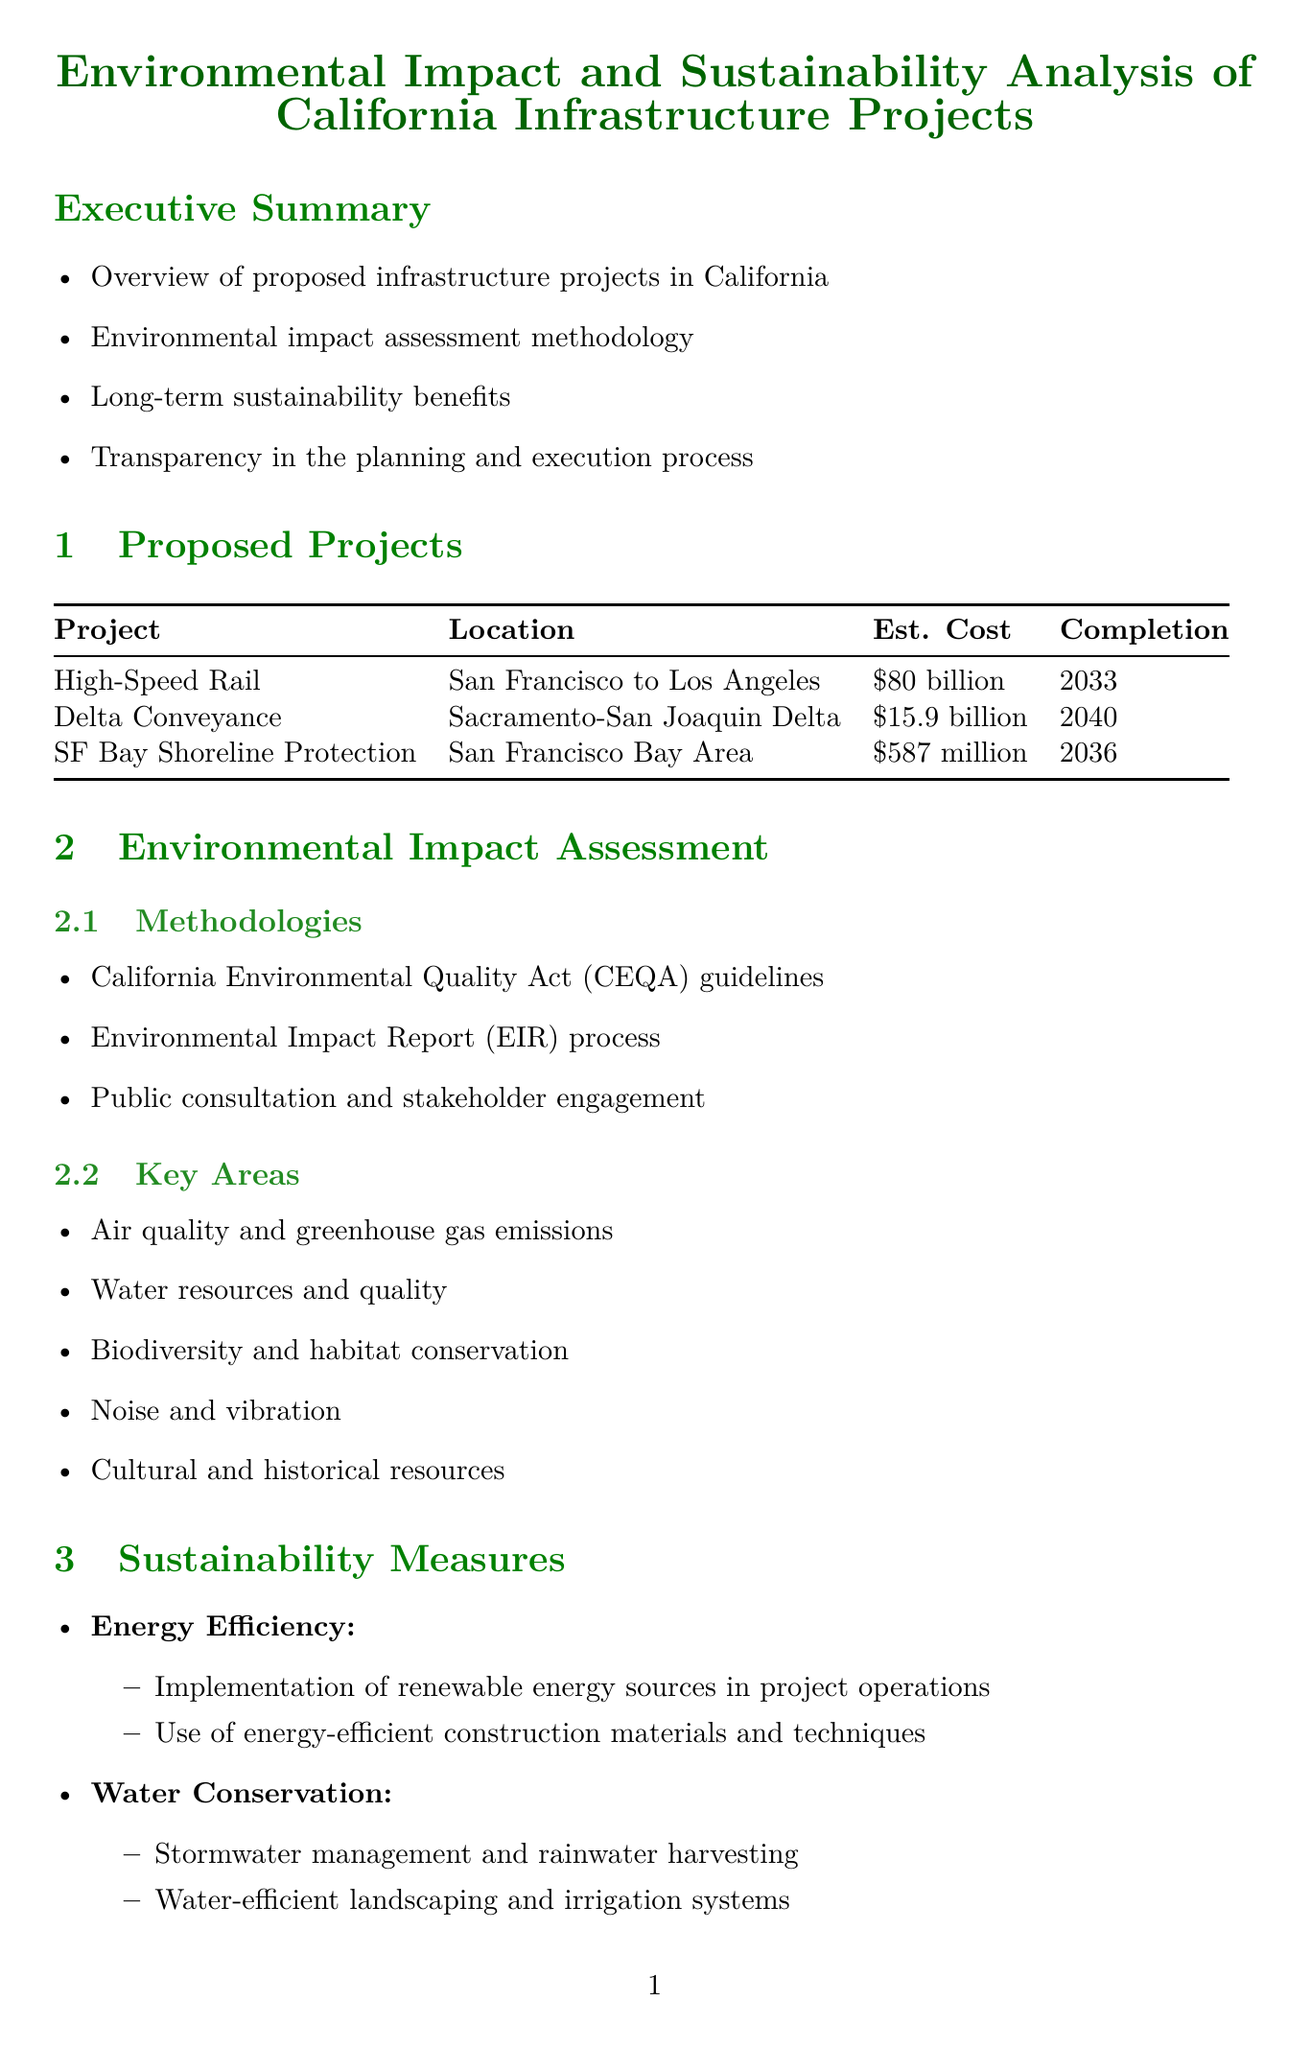What is the estimated cost of the High-Speed Rail Project? The estimated cost of the High-Speed Rail Project is listed in the document as $80 billion.
Answer: $80 billion What are the expected completion years for the Delta Conveyance Project? The expected completion year for the Delta Conveyance Project is clearly stated in the document as 2040.
Answer: 2040 Which assessment methodology is mentioned first in the Environmental Impact Assessment section? The methodologies section lists California Environmental Quality Act (CEQA) guidelines as the first assessment methodology.
Answer: California Environmental Quality Act (CEQA) guidelines What type of measures are included under the category of Water Conservation? Water Conservation measures include examples like stormwater management and rainwater harvesting listed in the sustainability measures.
Answer: Stormwater management and rainwater harvesting What initiative provides real-time updates on project progress? The initiative mentioned in the document that provides real-time updates on project progress is the California Infrastructure Transparency Portal.
Answer: California Infrastructure Transparency Portal How many long-term benefits are listed in the report? The document enumerates five distinct long-term benefits presented in the Long-Term Benefits section.
Answer: Five Who is the lead agency for transportation projects according to the key stakeholders? The California Department of Transportation (Caltrans) is identified in the document as the lead agency for transportation projects.
Answer: California Department of Transportation (Caltrans) What does the conclusion of the report signify about the proposed projects? The conclusion indicates a commitment to long-term sustainability and environmental stewardship in California.
Answer: Commitment to long-term sustainability and environmental stewardship Which type of meetings are held to address community concerns? The document specifies that Public Hearings and Town Halls are held regularly to gather input and address concerns.
Answer: Public Hearings and Town Halls 